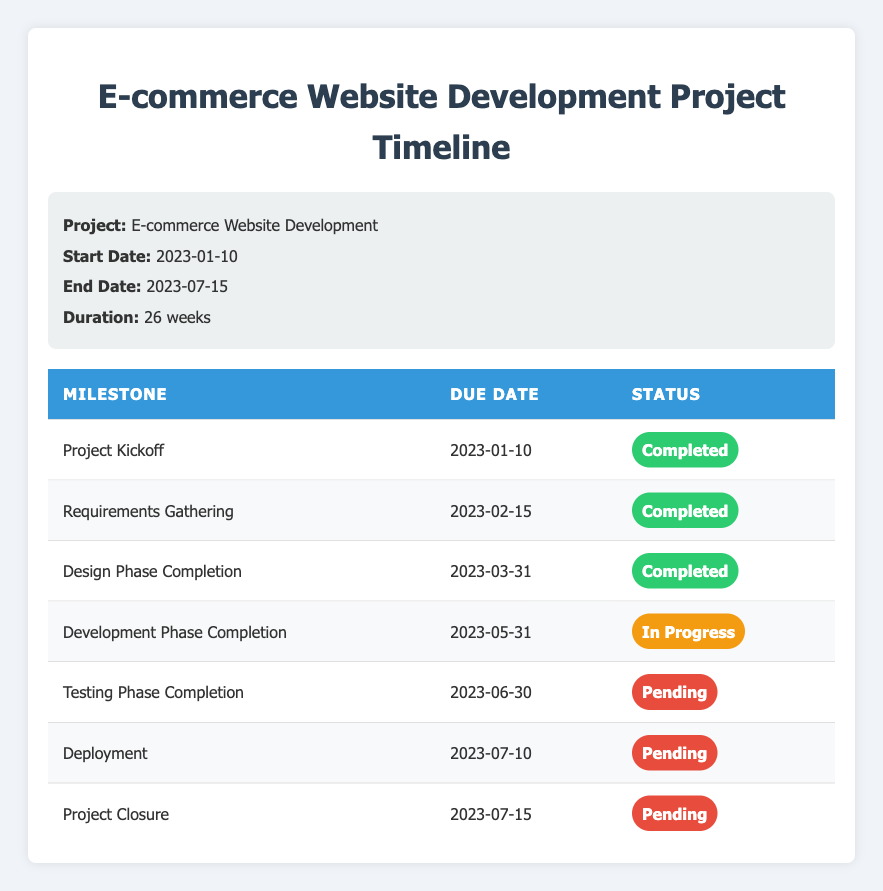What is the due date for the Design Phase Completion milestone? The table lists the due dates for each milestone under the "Due Date" column. For the "Design Phase Completion" milestone, the due date listed is "2023-03-31."
Answer: 2023-03-31 How many milestones are marked as completed? By looking at the table, we see that there are three milestones with the status "Completed," which include "Project Kickoff," "Requirements Gathering," and "Design Phase Completion."
Answer: 3 What is the status of the Development Phase Completion milestone? The table indicates that the "Development Phase Completion" milestone has the status "In Progress."
Answer: In Progress Is the Testing Phase Completion milestone due before the Deployment milestone? According to the due dates listed in the table, the "Testing Phase Completion" is due on "2023-06-30," while the "Deployment" milestone is due on "2023-07-10." Since June 30 is earlier than July 10, the answer is yes.
Answer: Yes How many weeks are there between the end date and the due date of Project Closure? The end date of the project is "2023-07-15," and the due date for the "Project Closure" milestone is also "2023-07-15." Therefore, the difference in weeks between these two dates is 0 weeks.
Answer: 0 weeks What percentage of the milestones are still pending? The total number of milestones is 7. There are 3 completed, 1 in progress, and 3 pending. To find the percentage pending, we calculate (3 pending / 7 total) * 100, which equals approximately 42.86%.
Answer: 42.86% Is the status of any milestones classified as "In Progress"? Yes, the "Development Phase Completion" milestone is classified as "In Progress," as indicated by the status in the table.
Answer: Yes What are the due dates of all completed milestones? The completed milestones listed in the table are "Project Kickoff" (2023-01-10), "Requirements Gathering" (2023-02-15), and "Design Phase Completion" (2023-03-31). Listing these together, the due dates are "2023-01-10," "2023-02-15," and "2023-03-31."
Answer: 2023-01-10, 2023-02-15, 2023-03-31 How many weeks remain until the Deployment milestone is due? The current date is not provided, but assuming the present date is before "2023-07-10," we can calculate the weeks remaining. If today were, for example, "2023-06-01," it would be 5 weeks until "2023-07-10." The exact answer depends on the specific current date.
Answer: Variable, depends on current date 